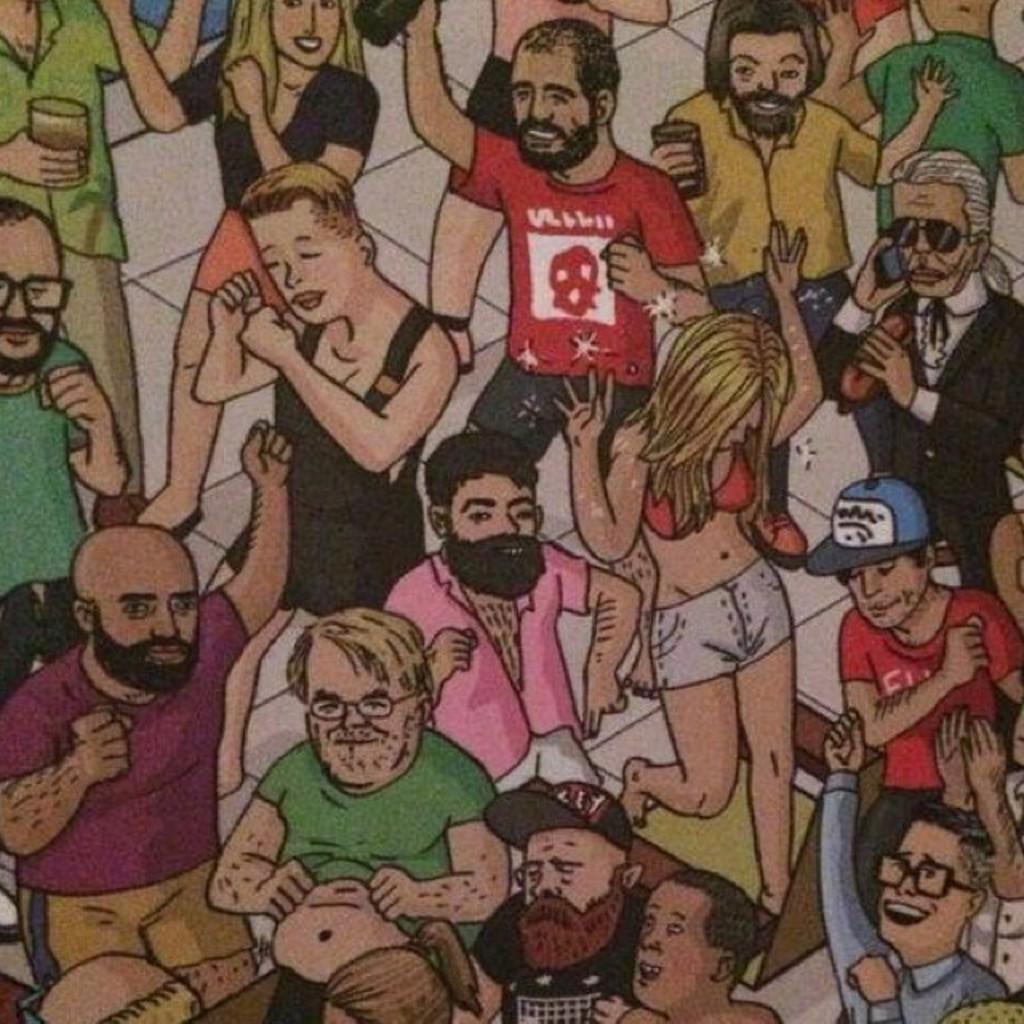In one or two sentences, can you explain what this image depicts? In this image we can see an animated picture of a few people dancing on the floor. 